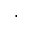<formula> <loc_0><loc_0><loc_500><loc_500>\cdot</formula> 